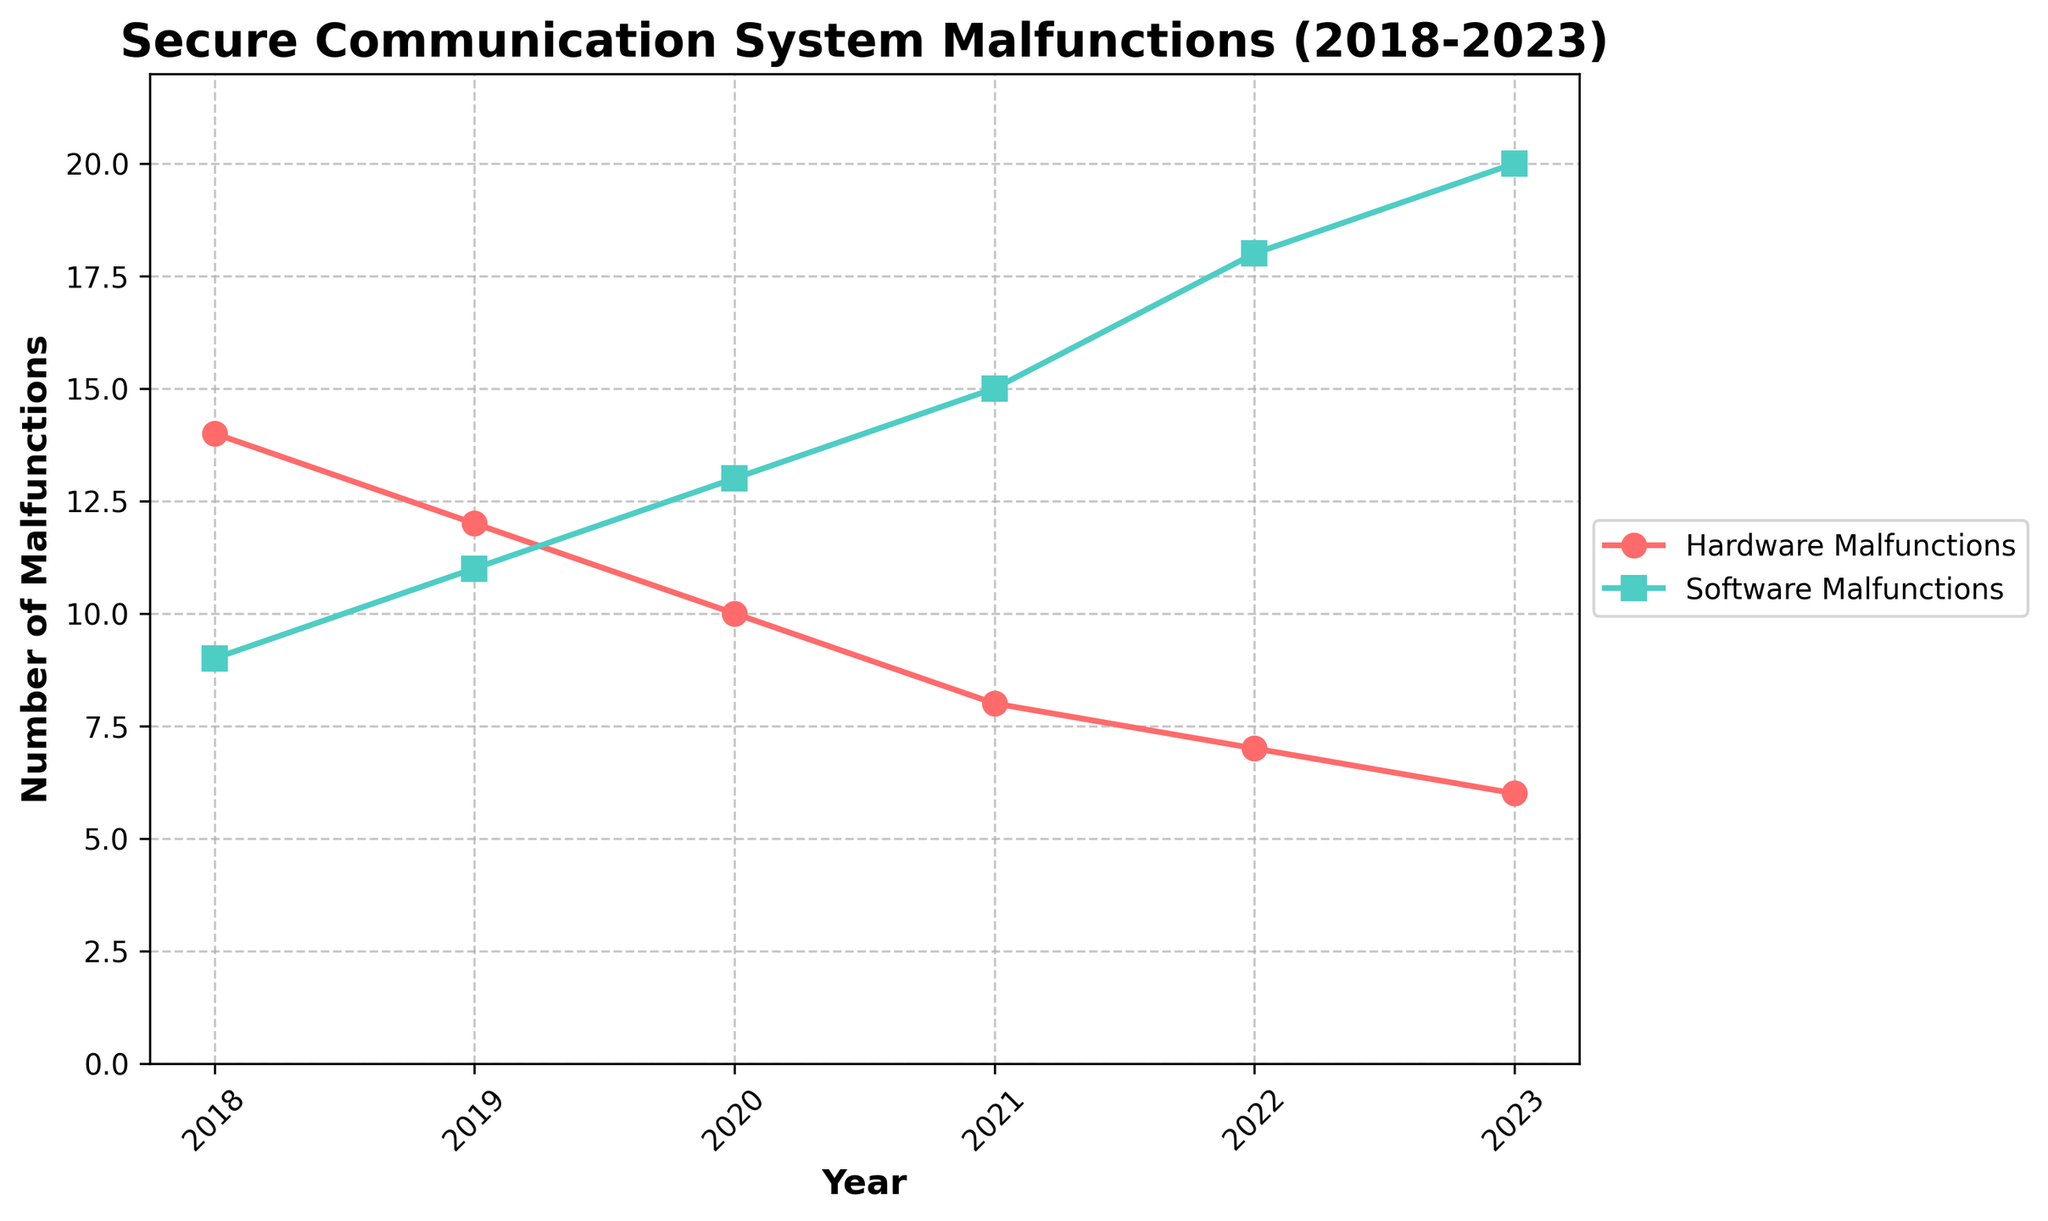What trend do you observe in hardware malfunctions over the period from 2018 to 2023? The figure shows that the number of hardware malfunctions declines gradually each year from 14 in 2018 to 6 in 2023. This indicates a downward trend in hardware malfunctions over the 5-year period.
Answer: A downward trend How do software malfunctions in 2020 compare to those in 2018? In 2020, there were 13 software malfunctions, whereas in 2018, there were 9 software malfunctions. To compare, 13 is greater than 9, indicating an increase in software malfunctions from 2018 to 2020.
Answer: Higher in 2020 What is the difference between hardware and software malfunctions in 2023? In 2023, hardware malfunctions stand at 6 while software malfunctions are at 20. The difference is calculated as 20 (software) - 6 (hardware) = 14.
Answer: 14 What has a greater average over the years 2018-2023, hardware or software malfunctions? To find the average, sum the values for each category over the years and divide by the number of years. Hardware: (14+12+10+8+7+6)/6 ≈ 9.5 Software: (9+11+13+15+18+20)/6 ≈ 14.33. Comparing the two averages, 14.33 is greater than 9.5.
Answer: Software malfunctions By what percentage did hardware malfunctions decrease from 2018 to 2023? The initial value (2018) is 14 and the final value (2023) is 6. The decrease is 14 - 6 = 8. The percentage decrease is (8/14) * 100 ≈ 57.14%.
Answer: 57.14% Which year had the smallest difference between hardware and software malfunctions? The differences for each year can be calculated as follows: 2018: 14-9=5, 2019: 12-11=1, 2020: 10-13=3, 2021: 8-15=7, 2022: 7-18=11, 2023: 6-20=14. The year with the smallest difference is 2019 with a difference of 1.
Answer: 2019 In which years did software malfunctions exceed hardware malfunctions by more than 10? To determine this, subtract hardware from software malfunctions for each year: 2018: 9-14=-5, 2019: 11-12=-1, 2020: 13-10=3, 2021: 15-8=7, 2022: 18-7=11, 2023: 20-6=14. In 2022 and 2023, software malfunctions exceeded hardware malfunctions by more than 10.
Answer: 2022 and 2023 What is the sum of hardware malfunctions over the entire period? Summing up the hardware malfunctions from each year: 14 + 12 + 10 + 8 + 7 + 6 = 57.
Answer: 57 How does the rate of decrease in hardware malfunctions compare to the rate of increase in software malfunctions from 2018 to 2023? The decrease in hardware malfunctions is from 14 to 6, a change of 8 over 6 years, so the rate is 8/6 ≈ 1.33 malfunctions per year. The increase in software malfunctions is from 9 to 20, a change of 11 over 6 years, so the rate is 11/6 ≈ 1.83 malfunctions per year. Comparing these rates, the rate of increase in software malfunctions (1.83) is higher than the rate of decrease in hardware malfunctions (1.33).
Answer: Software malfunctions increase faster What is the cumulative number of malfunctions for both hardware and software in 2021? The figure for 2021 shows 8 hardware malfunctions and 15 software malfunctions. The cumulative number is 8 + 15 = 23.
Answer: 23 